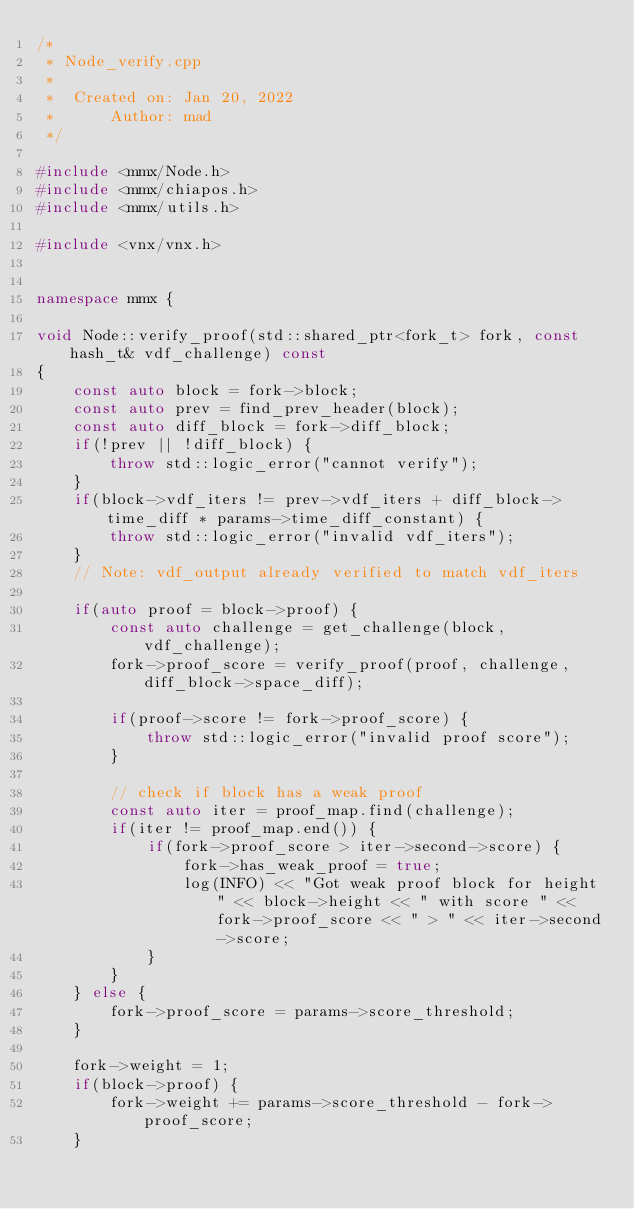Convert code to text. <code><loc_0><loc_0><loc_500><loc_500><_C++_>/*
 * Node_verify.cpp
 *
 *  Created on: Jan 20, 2022
 *      Author: mad
 */

#include <mmx/Node.h>
#include <mmx/chiapos.h>
#include <mmx/utils.h>

#include <vnx/vnx.h>


namespace mmx {

void Node::verify_proof(std::shared_ptr<fork_t> fork, const hash_t& vdf_challenge) const
{
	const auto block = fork->block;
	const auto prev = find_prev_header(block);
	const auto diff_block = fork->diff_block;
	if(!prev || !diff_block) {
		throw std::logic_error("cannot verify");
	}
	if(block->vdf_iters != prev->vdf_iters + diff_block->time_diff * params->time_diff_constant) {
		throw std::logic_error("invalid vdf_iters");
	}
	// Note: vdf_output already verified to match vdf_iters

	if(auto proof = block->proof) {
		const auto challenge = get_challenge(block, vdf_challenge);
		fork->proof_score = verify_proof(proof, challenge, diff_block->space_diff);

		if(proof->score != fork->proof_score) {
			throw std::logic_error("invalid proof score");
		}

		// check if block has a weak proof
		const auto iter = proof_map.find(challenge);
		if(iter != proof_map.end()) {
			if(fork->proof_score > iter->second->score) {
				fork->has_weak_proof = true;
				log(INFO) << "Got weak proof block for height " << block->height << " with score " << fork->proof_score << " > " << iter->second->score;
			}
		}
	} else {
		fork->proof_score = params->score_threshold;
	}

	fork->weight = 1;
	if(block->proof) {
		fork->weight += params->score_threshold - fork->proof_score;
	}</code> 